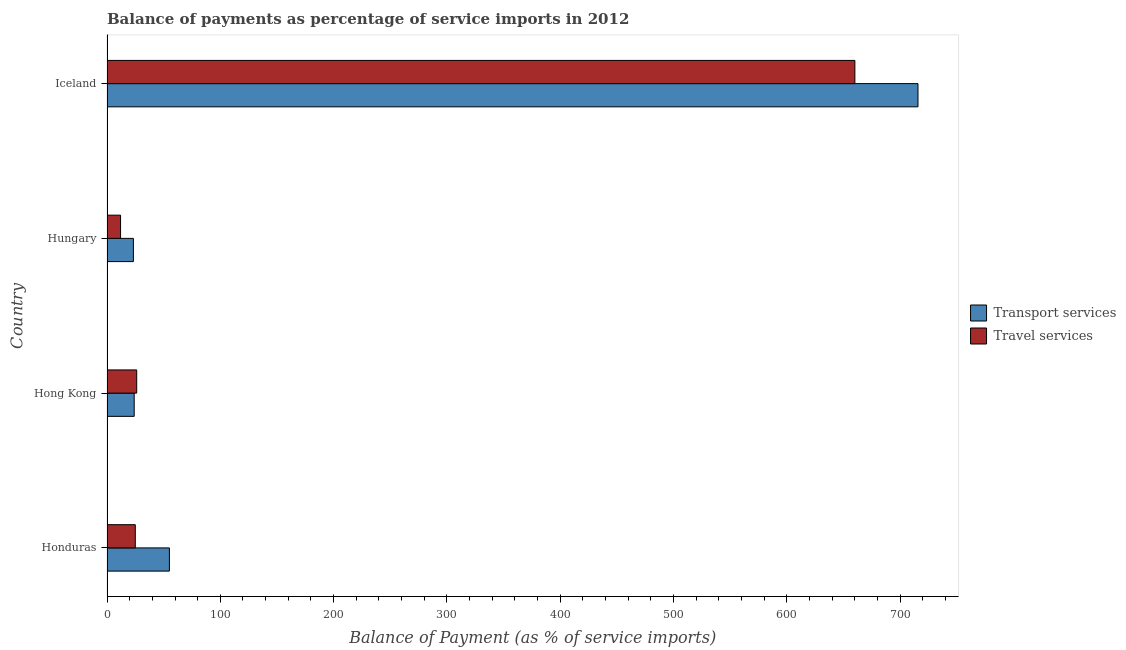Are the number of bars per tick equal to the number of legend labels?
Give a very brief answer. Yes. Are the number of bars on each tick of the Y-axis equal?
Your answer should be very brief. Yes. How many bars are there on the 2nd tick from the top?
Your answer should be compact. 2. How many bars are there on the 4th tick from the bottom?
Your response must be concise. 2. What is the label of the 2nd group of bars from the top?
Give a very brief answer. Hungary. In how many cases, is the number of bars for a given country not equal to the number of legend labels?
Make the answer very short. 0. What is the balance of payments of travel services in Iceland?
Provide a succinct answer. 659.94. Across all countries, what is the maximum balance of payments of transport services?
Offer a very short reply. 715.64. Across all countries, what is the minimum balance of payments of travel services?
Provide a short and direct response. 11.97. In which country was the balance of payments of transport services minimum?
Keep it short and to the point. Hungary. What is the total balance of payments of transport services in the graph?
Make the answer very short. 818. What is the difference between the balance of payments of travel services in Honduras and that in Hong Kong?
Provide a succinct answer. -1.23. What is the difference between the balance of payments of travel services in Honduras and the balance of payments of transport services in Hong Kong?
Make the answer very short. 0.98. What is the average balance of payments of transport services per country?
Make the answer very short. 204.5. What is the difference between the balance of payments of travel services and balance of payments of transport services in Iceland?
Ensure brevity in your answer.  -55.7. What is the ratio of the balance of payments of travel services in Honduras to that in Hungary?
Provide a short and direct response. 2.09. Is the balance of payments of transport services in Hungary less than that in Iceland?
Provide a short and direct response. Yes. What is the difference between the highest and the second highest balance of payments of travel services?
Give a very brief answer. 633.74. What is the difference between the highest and the lowest balance of payments of transport services?
Your answer should be compact. 692.34. In how many countries, is the balance of payments of travel services greater than the average balance of payments of travel services taken over all countries?
Provide a short and direct response. 1. Is the sum of the balance of payments of travel services in Hungary and Iceland greater than the maximum balance of payments of transport services across all countries?
Your response must be concise. No. What does the 2nd bar from the top in Iceland represents?
Make the answer very short. Transport services. What does the 1st bar from the bottom in Hong Kong represents?
Your response must be concise. Transport services. How many bars are there?
Keep it short and to the point. 8. What is the difference between two consecutive major ticks on the X-axis?
Give a very brief answer. 100. Does the graph contain any zero values?
Your response must be concise. No. How many legend labels are there?
Make the answer very short. 2. How are the legend labels stacked?
Keep it short and to the point. Vertical. What is the title of the graph?
Give a very brief answer. Balance of payments as percentage of service imports in 2012. Does "Non-solid fuel" appear as one of the legend labels in the graph?
Keep it short and to the point. No. What is the label or title of the X-axis?
Provide a succinct answer. Balance of Payment (as % of service imports). What is the label or title of the Y-axis?
Provide a short and direct response. Country. What is the Balance of Payment (as % of service imports) of Transport services in Honduras?
Make the answer very short. 55.06. What is the Balance of Payment (as % of service imports) of Travel services in Honduras?
Your response must be concise. 24.97. What is the Balance of Payment (as % of service imports) of Transport services in Hong Kong?
Offer a terse response. 23.99. What is the Balance of Payment (as % of service imports) of Travel services in Hong Kong?
Your answer should be very brief. 26.2. What is the Balance of Payment (as % of service imports) in Transport services in Hungary?
Your answer should be compact. 23.3. What is the Balance of Payment (as % of service imports) of Travel services in Hungary?
Keep it short and to the point. 11.97. What is the Balance of Payment (as % of service imports) in Transport services in Iceland?
Provide a succinct answer. 715.64. What is the Balance of Payment (as % of service imports) of Travel services in Iceland?
Give a very brief answer. 659.94. Across all countries, what is the maximum Balance of Payment (as % of service imports) in Transport services?
Keep it short and to the point. 715.64. Across all countries, what is the maximum Balance of Payment (as % of service imports) of Travel services?
Keep it short and to the point. 659.94. Across all countries, what is the minimum Balance of Payment (as % of service imports) of Transport services?
Your answer should be compact. 23.3. Across all countries, what is the minimum Balance of Payment (as % of service imports) in Travel services?
Give a very brief answer. 11.97. What is the total Balance of Payment (as % of service imports) in Transport services in the graph?
Provide a succinct answer. 818. What is the total Balance of Payment (as % of service imports) in Travel services in the graph?
Give a very brief answer. 723.08. What is the difference between the Balance of Payment (as % of service imports) of Transport services in Honduras and that in Hong Kong?
Provide a short and direct response. 31.07. What is the difference between the Balance of Payment (as % of service imports) in Travel services in Honduras and that in Hong Kong?
Keep it short and to the point. -1.23. What is the difference between the Balance of Payment (as % of service imports) of Transport services in Honduras and that in Hungary?
Offer a terse response. 31.77. What is the difference between the Balance of Payment (as % of service imports) of Travel services in Honduras and that in Hungary?
Give a very brief answer. 13. What is the difference between the Balance of Payment (as % of service imports) in Transport services in Honduras and that in Iceland?
Make the answer very short. -660.58. What is the difference between the Balance of Payment (as % of service imports) of Travel services in Honduras and that in Iceland?
Your answer should be very brief. -634.97. What is the difference between the Balance of Payment (as % of service imports) of Transport services in Hong Kong and that in Hungary?
Offer a terse response. 0.69. What is the difference between the Balance of Payment (as % of service imports) in Travel services in Hong Kong and that in Hungary?
Give a very brief answer. 14.23. What is the difference between the Balance of Payment (as % of service imports) in Transport services in Hong Kong and that in Iceland?
Offer a terse response. -691.65. What is the difference between the Balance of Payment (as % of service imports) in Travel services in Hong Kong and that in Iceland?
Provide a succinct answer. -633.74. What is the difference between the Balance of Payment (as % of service imports) of Transport services in Hungary and that in Iceland?
Make the answer very short. -692.34. What is the difference between the Balance of Payment (as % of service imports) of Travel services in Hungary and that in Iceland?
Make the answer very short. -647.97. What is the difference between the Balance of Payment (as % of service imports) of Transport services in Honduras and the Balance of Payment (as % of service imports) of Travel services in Hong Kong?
Your answer should be very brief. 28.86. What is the difference between the Balance of Payment (as % of service imports) of Transport services in Honduras and the Balance of Payment (as % of service imports) of Travel services in Hungary?
Your answer should be very brief. 43.09. What is the difference between the Balance of Payment (as % of service imports) in Transport services in Honduras and the Balance of Payment (as % of service imports) in Travel services in Iceland?
Your answer should be very brief. -604.88. What is the difference between the Balance of Payment (as % of service imports) in Transport services in Hong Kong and the Balance of Payment (as % of service imports) in Travel services in Hungary?
Offer a terse response. 12.02. What is the difference between the Balance of Payment (as % of service imports) of Transport services in Hong Kong and the Balance of Payment (as % of service imports) of Travel services in Iceland?
Keep it short and to the point. -635.95. What is the difference between the Balance of Payment (as % of service imports) in Transport services in Hungary and the Balance of Payment (as % of service imports) in Travel services in Iceland?
Offer a very short reply. -636.64. What is the average Balance of Payment (as % of service imports) of Transport services per country?
Your answer should be very brief. 204.5. What is the average Balance of Payment (as % of service imports) of Travel services per country?
Make the answer very short. 180.77. What is the difference between the Balance of Payment (as % of service imports) of Transport services and Balance of Payment (as % of service imports) of Travel services in Honduras?
Provide a succinct answer. 30.09. What is the difference between the Balance of Payment (as % of service imports) of Transport services and Balance of Payment (as % of service imports) of Travel services in Hong Kong?
Your answer should be very brief. -2.21. What is the difference between the Balance of Payment (as % of service imports) in Transport services and Balance of Payment (as % of service imports) in Travel services in Hungary?
Your answer should be compact. 11.33. What is the difference between the Balance of Payment (as % of service imports) in Transport services and Balance of Payment (as % of service imports) in Travel services in Iceland?
Your response must be concise. 55.7. What is the ratio of the Balance of Payment (as % of service imports) in Transport services in Honduras to that in Hong Kong?
Provide a short and direct response. 2.3. What is the ratio of the Balance of Payment (as % of service imports) in Travel services in Honduras to that in Hong Kong?
Your answer should be very brief. 0.95. What is the ratio of the Balance of Payment (as % of service imports) in Transport services in Honduras to that in Hungary?
Give a very brief answer. 2.36. What is the ratio of the Balance of Payment (as % of service imports) of Travel services in Honduras to that in Hungary?
Provide a succinct answer. 2.09. What is the ratio of the Balance of Payment (as % of service imports) in Transport services in Honduras to that in Iceland?
Your answer should be very brief. 0.08. What is the ratio of the Balance of Payment (as % of service imports) in Travel services in Honduras to that in Iceland?
Provide a short and direct response. 0.04. What is the ratio of the Balance of Payment (as % of service imports) of Transport services in Hong Kong to that in Hungary?
Offer a very short reply. 1.03. What is the ratio of the Balance of Payment (as % of service imports) of Travel services in Hong Kong to that in Hungary?
Ensure brevity in your answer.  2.19. What is the ratio of the Balance of Payment (as % of service imports) of Transport services in Hong Kong to that in Iceland?
Provide a succinct answer. 0.03. What is the ratio of the Balance of Payment (as % of service imports) in Travel services in Hong Kong to that in Iceland?
Keep it short and to the point. 0.04. What is the ratio of the Balance of Payment (as % of service imports) of Transport services in Hungary to that in Iceland?
Your answer should be compact. 0.03. What is the ratio of the Balance of Payment (as % of service imports) in Travel services in Hungary to that in Iceland?
Offer a very short reply. 0.02. What is the difference between the highest and the second highest Balance of Payment (as % of service imports) of Transport services?
Provide a succinct answer. 660.58. What is the difference between the highest and the second highest Balance of Payment (as % of service imports) in Travel services?
Your response must be concise. 633.74. What is the difference between the highest and the lowest Balance of Payment (as % of service imports) of Transport services?
Make the answer very short. 692.34. What is the difference between the highest and the lowest Balance of Payment (as % of service imports) in Travel services?
Your answer should be very brief. 647.97. 